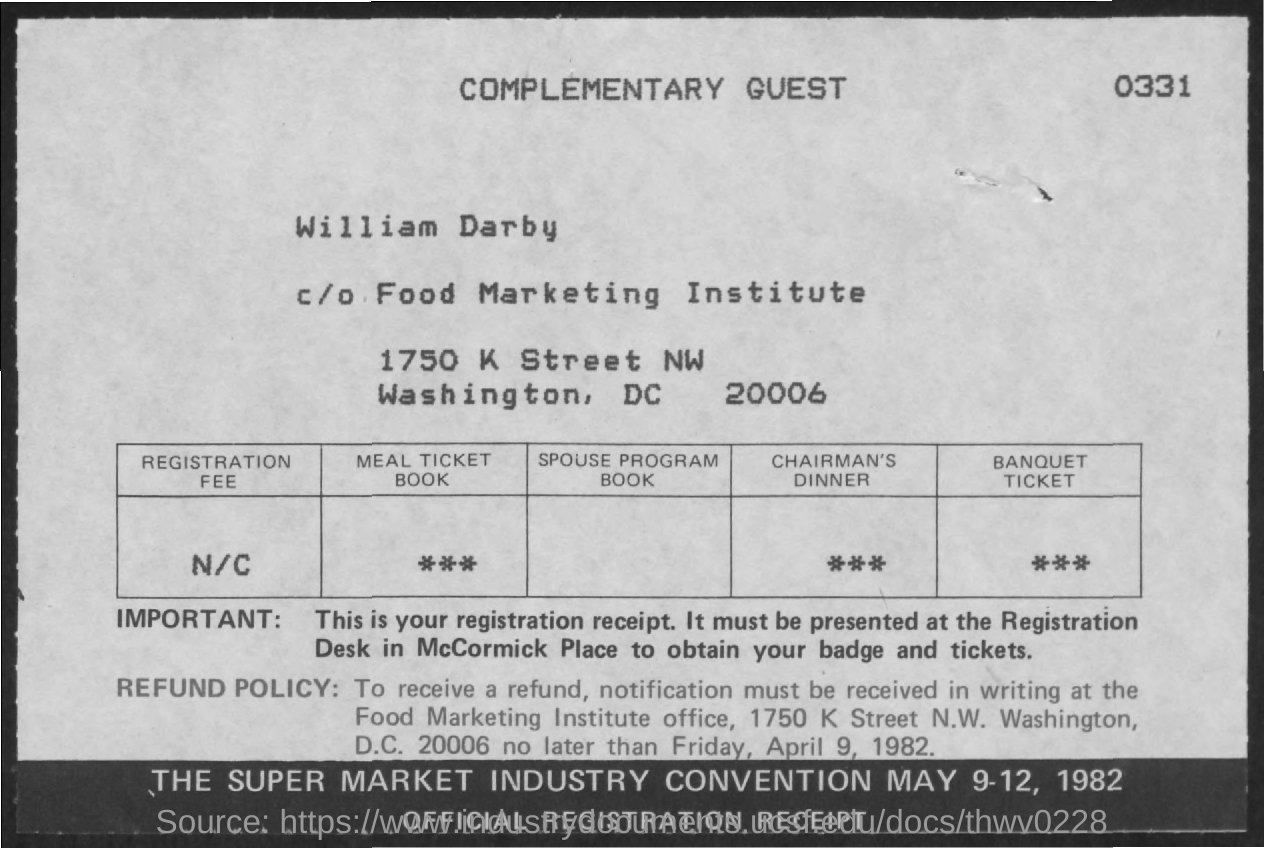Point out several critical features in this image. The refund notification must be received no later than Friday, April 9, 1982. 